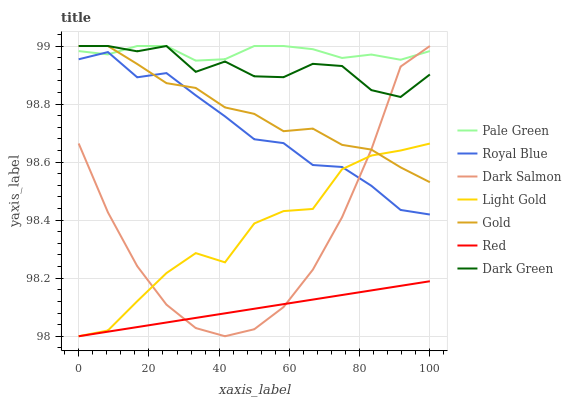Does Red have the minimum area under the curve?
Answer yes or no. Yes. Does Pale Green have the maximum area under the curve?
Answer yes or no. Yes. Does Dark Salmon have the minimum area under the curve?
Answer yes or no. No. Does Dark Salmon have the maximum area under the curve?
Answer yes or no. No. Is Red the smoothest?
Answer yes or no. Yes. Is Light Gold the roughest?
Answer yes or no. Yes. Is Dark Salmon the smoothest?
Answer yes or no. No. Is Dark Salmon the roughest?
Answer yes or no. No. Does Light Gold have the lowest value?
Answer yes or no. Yes. Does Dark Salmon have the lowest value?
Answer yes or no. No. Does Dark Green have the highest value?
Answer yes or no. Yes. Does Royal Blue have the highest value?
Answer yes or no. No. Is Red less than Gold?
Answer yes or no. Yes. Is Gold greater than Red?
Answer yes or no. Yes. Does Red intersect Dark Salmon?
Answer yes or no. Yes. Is Red less than Dark Salmon?
Answer yes or no. No. Is Red greater than Dark Salmon?
Answer yes or no. No. Does Red intersect Gold?
Answer yes or no. No. 